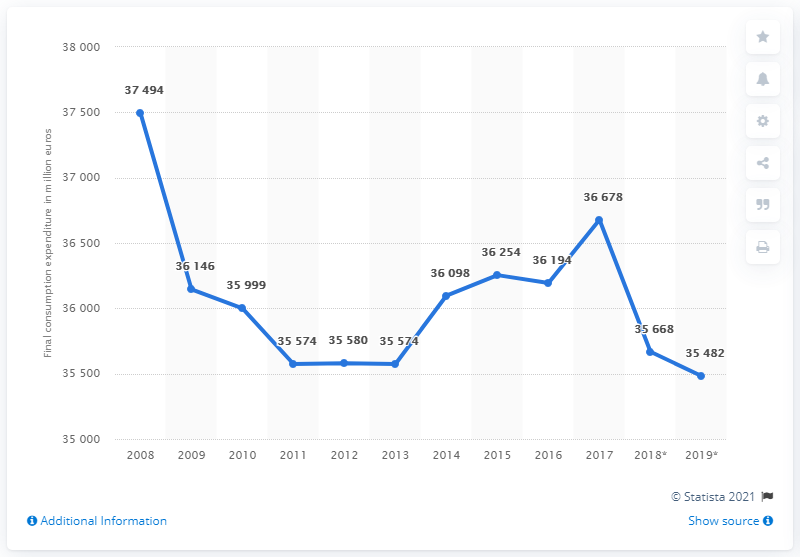Highlight a few significant elements in this photo. In 2019, the total expenditure of French households on clothing was 35,482 million euros. In 2019, the total expenditure of French households on clothing was 35,482. 